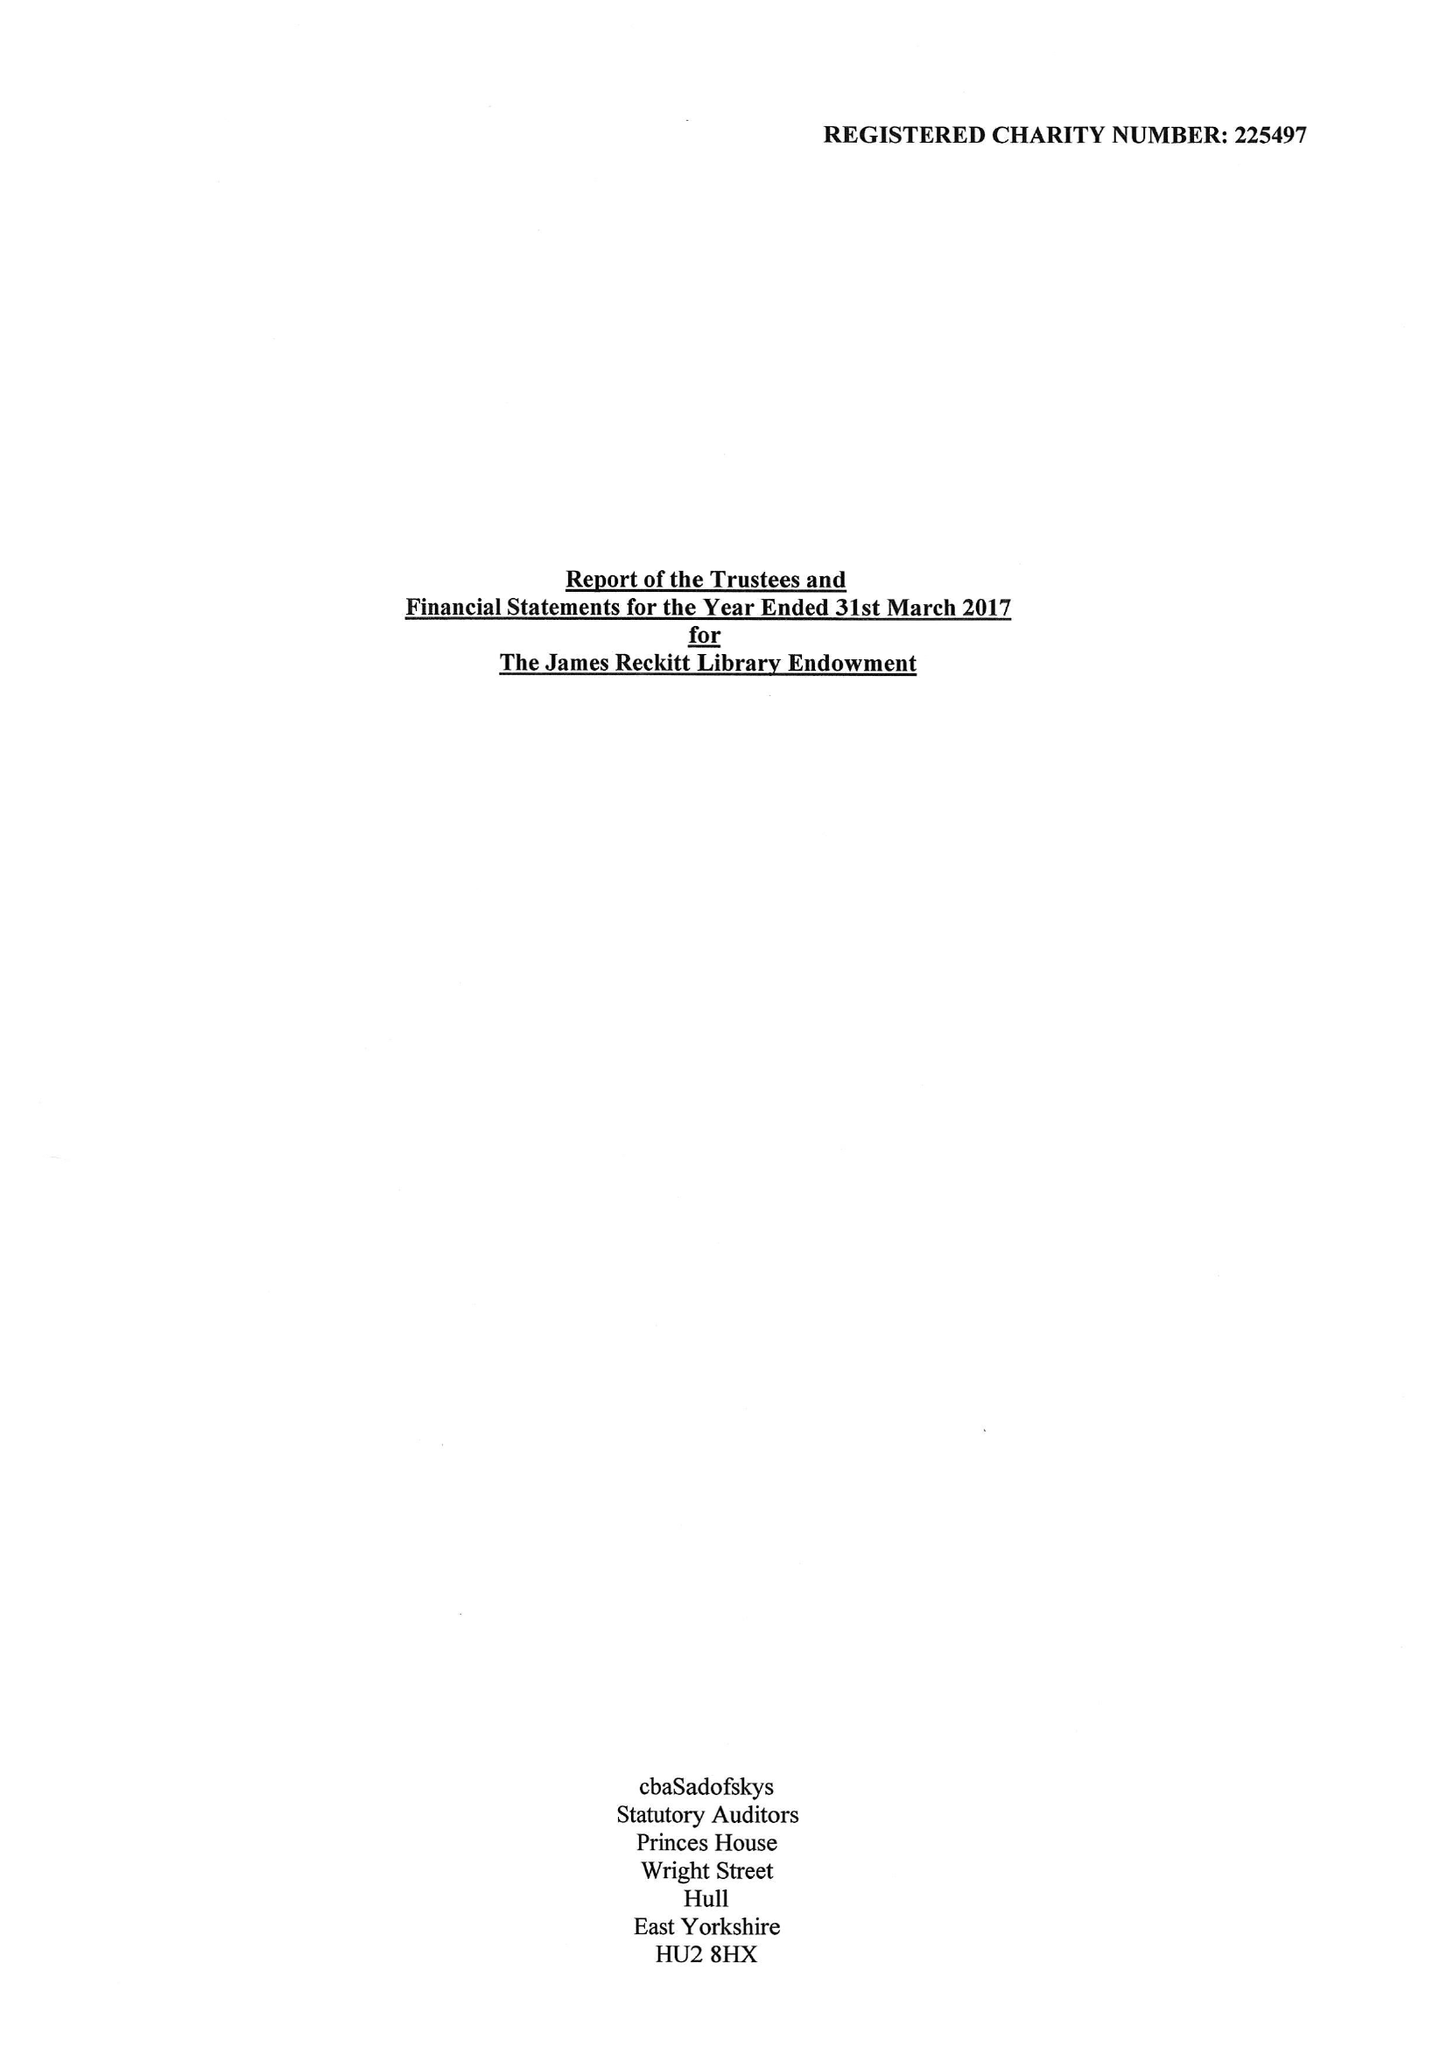What is the value for the address__post_town?
Answer the question using a single word or phrase. HULL 